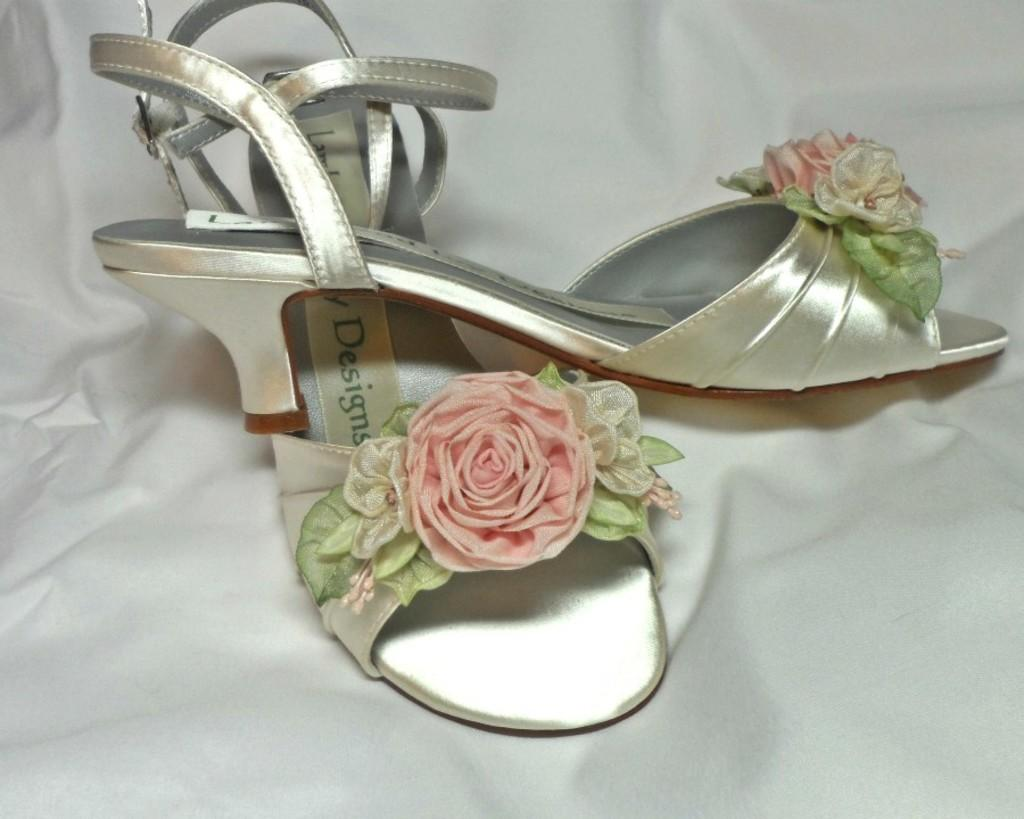What type of footwear is visible in the image? There is a pair of footwear in the image. Where are the footwear placed? The footwear is placed on a cloth. What is the name of the person who owns the footwear in the image? There is no information about the owner of the footwear in the image, so we cannot determine their name. 